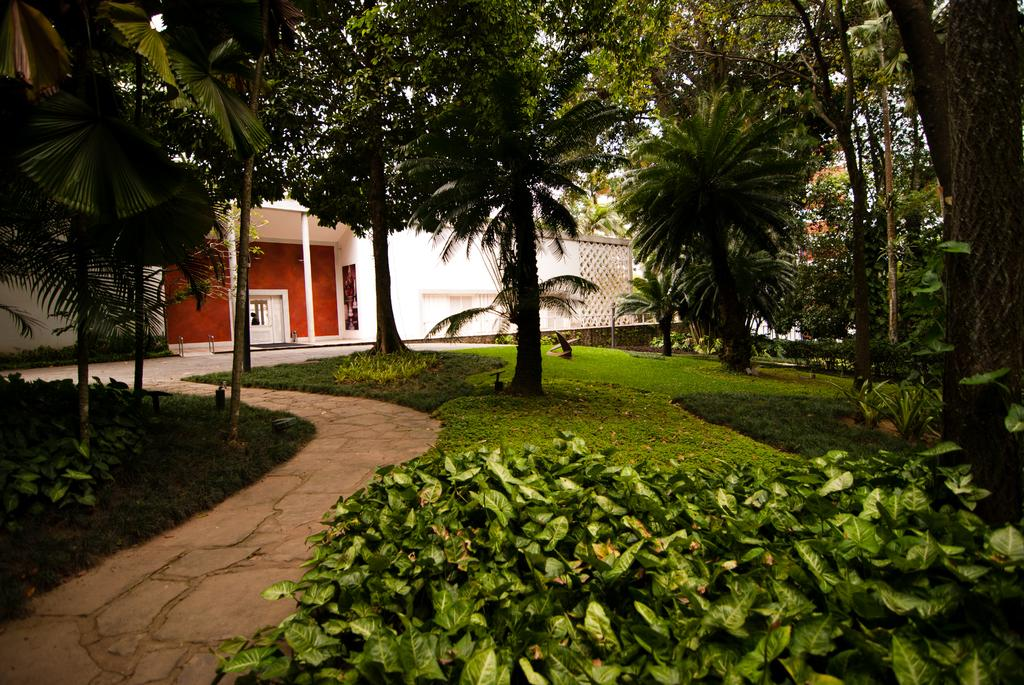What type of vegetation can be seen in the image? There are shrubs and grass in the image. What kind of path is present in the image? There is a stone walkway in the image. What other type of plant is visible in the image? There are trees in the image. What can be seen in the background of the image? There is a building in the background of the image. What type of net is being used for the activity in the image? There is no net or activity present in the image; it features vegetation, a stone walkway, trees, and a building in the background. 